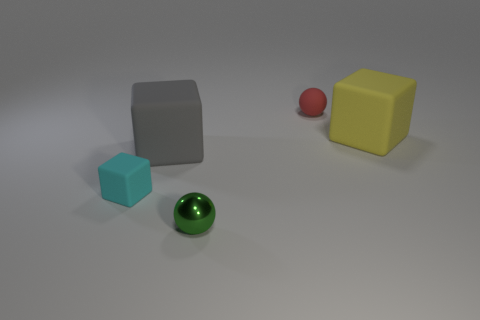How many spheres are either big gray things or rubber objects?
Keep it short and to the point. 1. Are there an equal number of small green metal objects left of the tiny green object and yellow cubes on the left side of the small red object?
Your answer should be compact. Yes. What is the color of the tiny block?
Offer a very short reply. Cyan. How many things are either big things that are in front of the large yellow thing or small cyan shiny spheres?
Your response must be concise. 1. There is a sphere that is right of the green metallic thing; is its size the same as the thing that is in front of the small cyan rubber thing?
Make the answer very short. Yes. Is there any other thing that is the same material as the tiny green ball?
Provide a short and direct response. No. What number of things are things behind the small green sphere or tiny cyan rubber objects in front of the yellow cube?
Your answer should be compact. 4. Are the large gray object and the ball on the left side of the tiny red ball made of the same material?
Provide a short and direct response. No. There is a matte object that is both to the left of the metallic sphere and behind the small cyan rubber thing; what is its shape?
Your response must be concise. Cube. How many other things are there of the same color as the shiny thing?
Your answer should be compact. 0. 